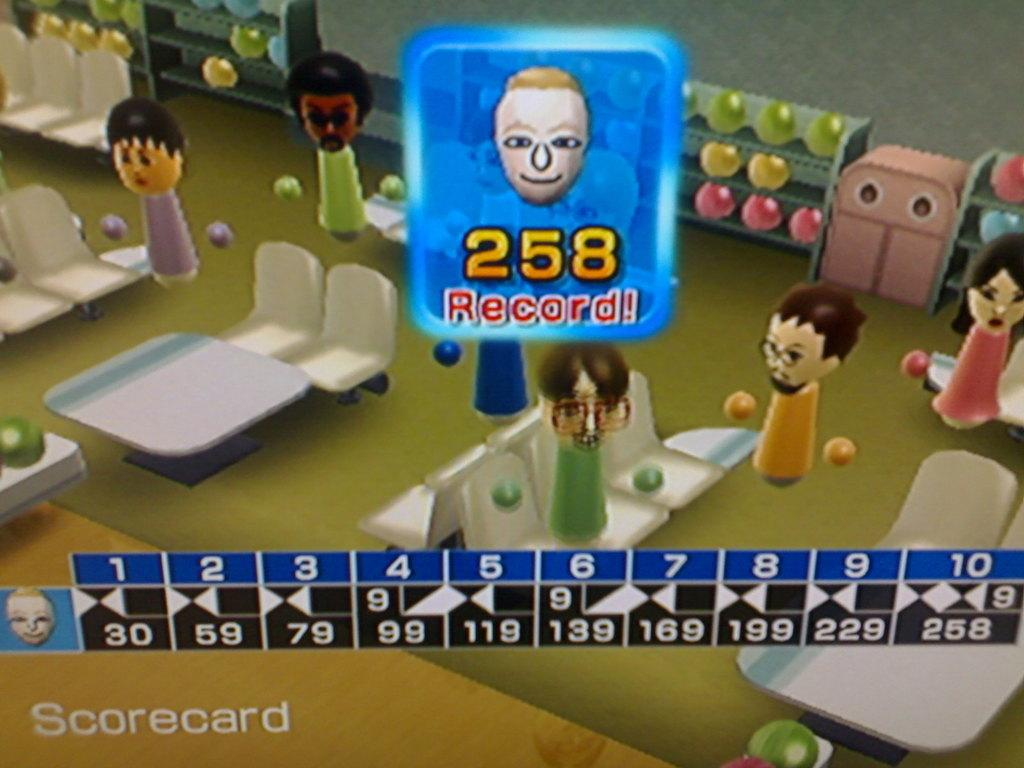What type of screen is depicted in the image? The image contains a cartoon gaming screen. What can be seen on the screen? There is a scoreboard visible in the image. What other objects are present in the image? There are dolls sitting on chairs in the image. How many cherries are on the gaming screen in the image? There are no cherries present on the gaming screen in the image. What letters can be seen on the dolls' shirts in the image? There is no information about letters on the dolls' shirts in the provided facts. 